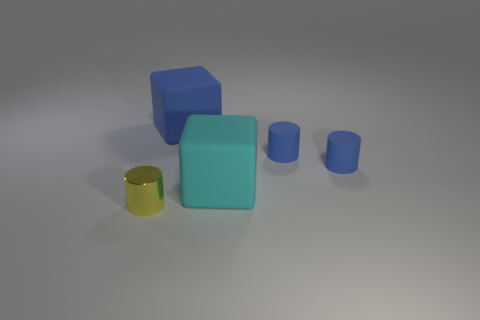How many objects are small cylinders behind the metal object or cubes that are behind the cyan rubber object? 3 